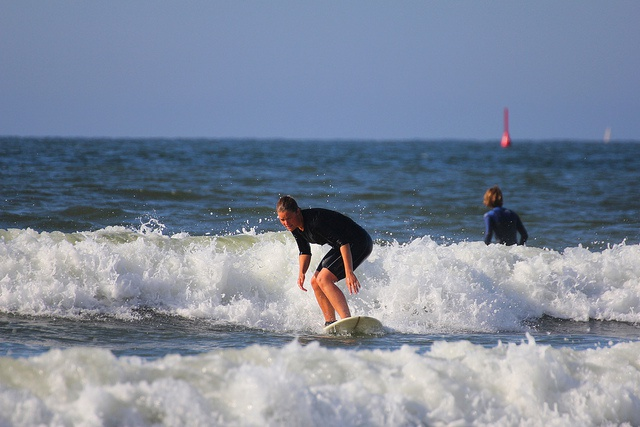Describe the objects in this image and their specific colors. I can see people in gray, black, maroon, and salmon tones, people in gray, black, navy, and blue tones, and surfboard in gray, darkgreen, and darkgray tones in this image. 